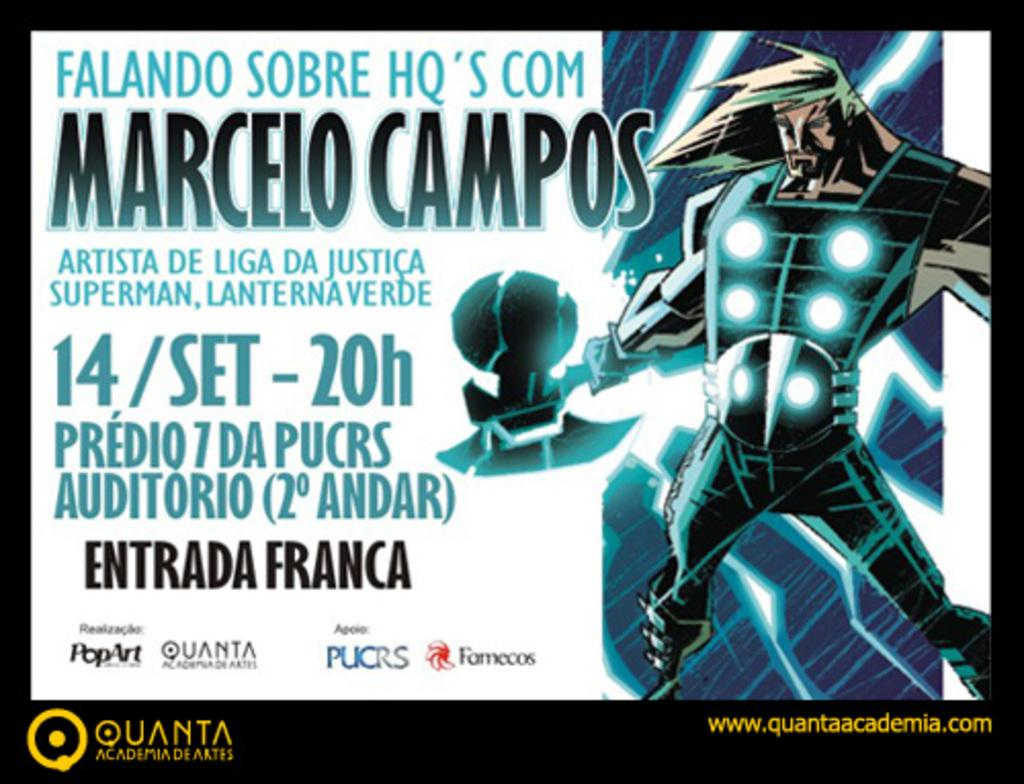<image>
Render a clear and concise summary of the photo. a poster that is labeled 'quanta academia de artes' at the bottom 